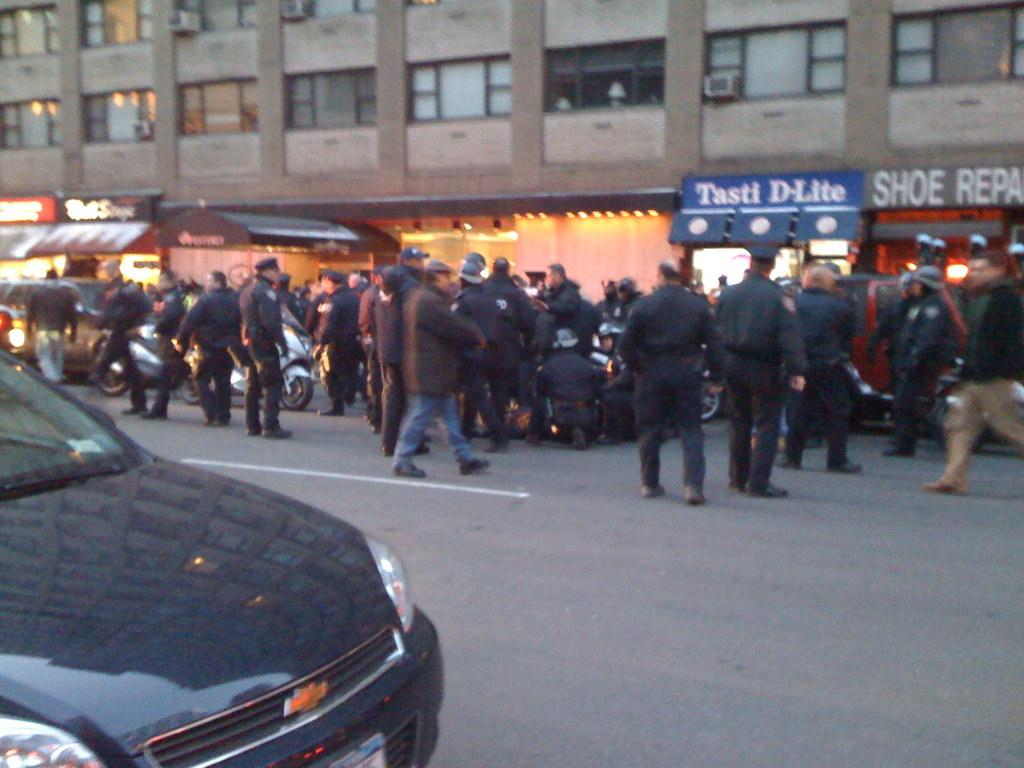What can be seen on the road in the image? There are vehicles on the road in the image. What are the people doing in front of the building in the image? The people are standing in front of a building in the image. What can be seen in the background of the image? There are lights visible in the background of the image. What type of chin can be seen on the doll in the image? There is no doll present in the image, so it is not possible to answer that question. 